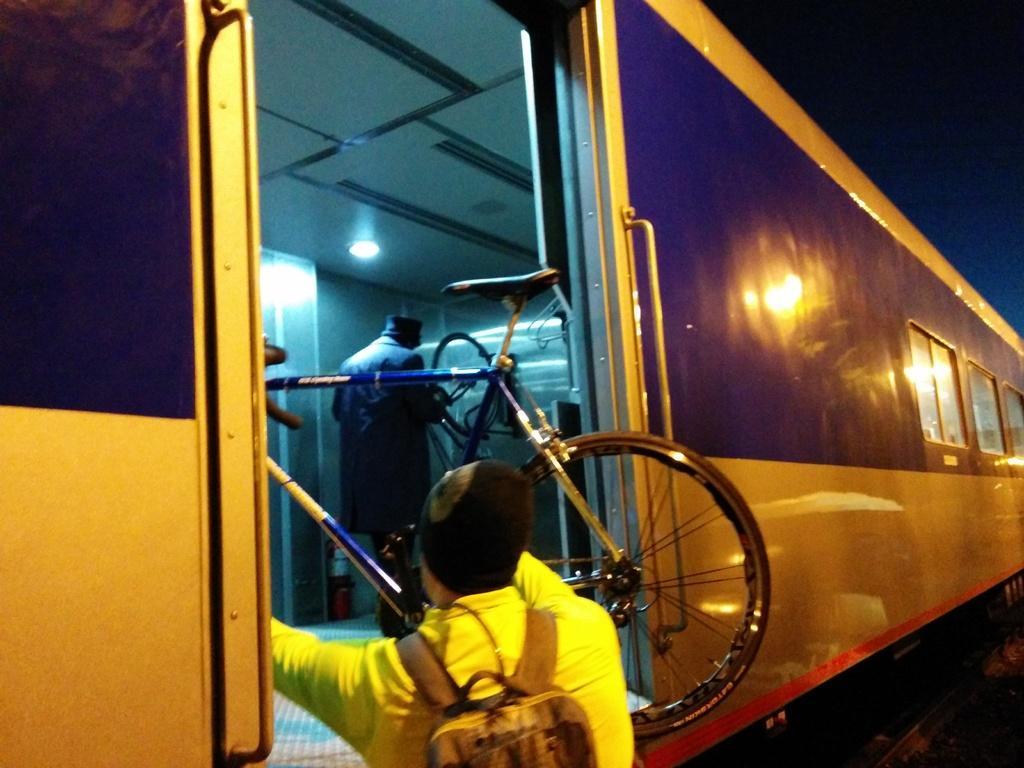Please provide a concise description of this image. In this image we can see a man is standing, he is wearing yellow color dress and carrying bag, he is holding a bicycle in his hand and keeping the bicycle in the train 